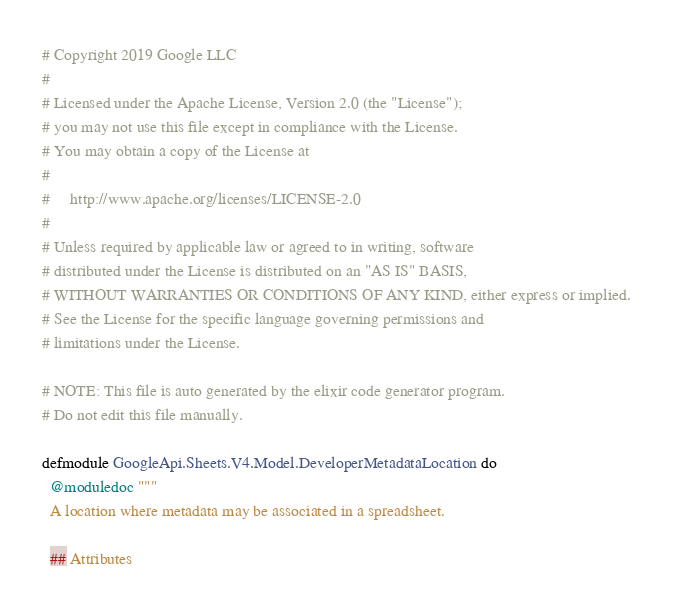Convert code to text. <code><loc_0><loc_0><loc_500><loc_500><_Elixir_># Copyright 2019 Google LLC
#
# Licensed under the Apache License, Version 2.0 (the "License");
# you may not use this file except in compliance with the License.
# You may obtain a copy of the License at
#
#     http://www.apache.org/licenses/LICENSE-2.0
#
# Unless required by applicable law or agreed to in writing, software
# distributed under the License is distributed on an "AS IS" BASIS,
# WITHOUT WARRANTIES OR CONDITIONS OF ANY KIND, either express or implied.
# See the License for the specific language governing permissions and
# limitations under the License.

# NOTE: This file is auto generated by the elixir code generator program.
# Do not edit this file manually.

defmodule GoogleApi.Sheets.V4.Model.DeveloperMetadataLocation do
  @moduledoc """
  A location where metadata may be associated in a spreadsheet.

  ## Attributes
</code> 